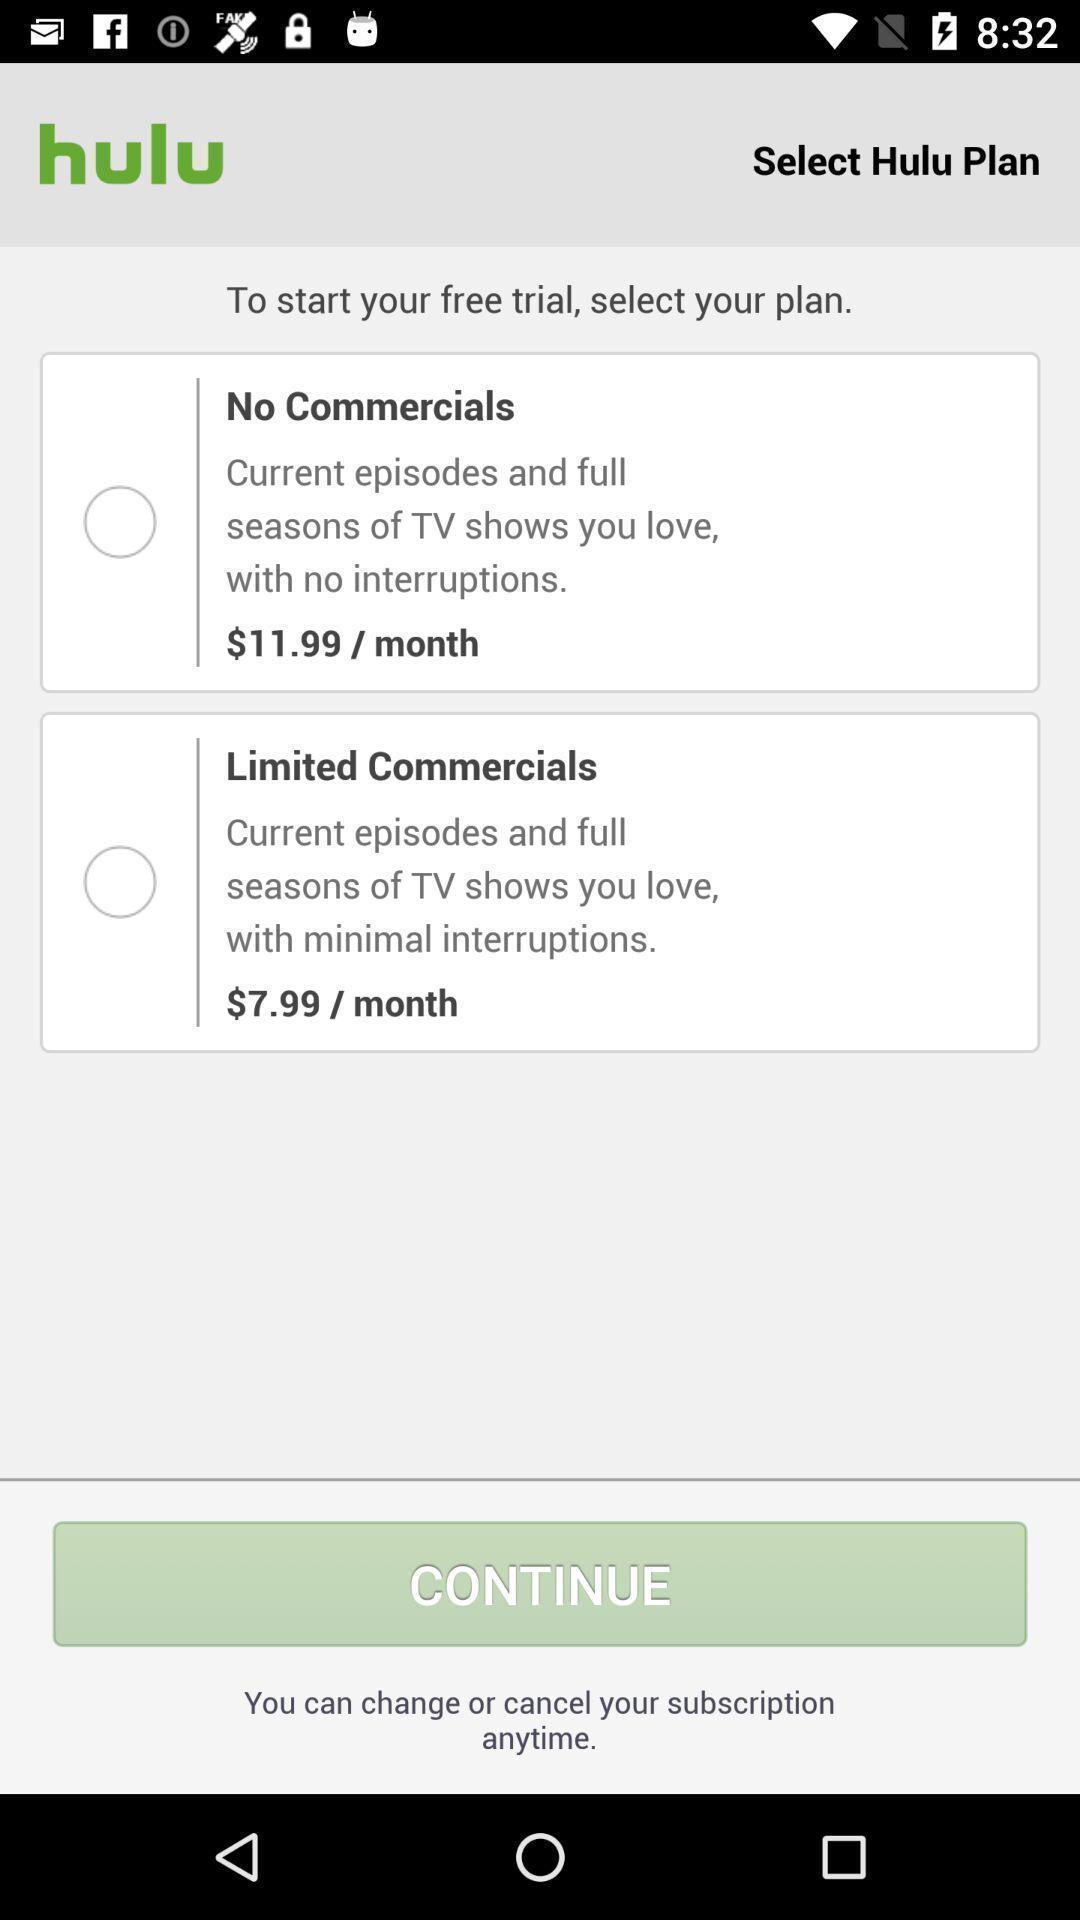Describe the visual elements of this screenshot. Screen shows multiple plan options in a streaming application. 